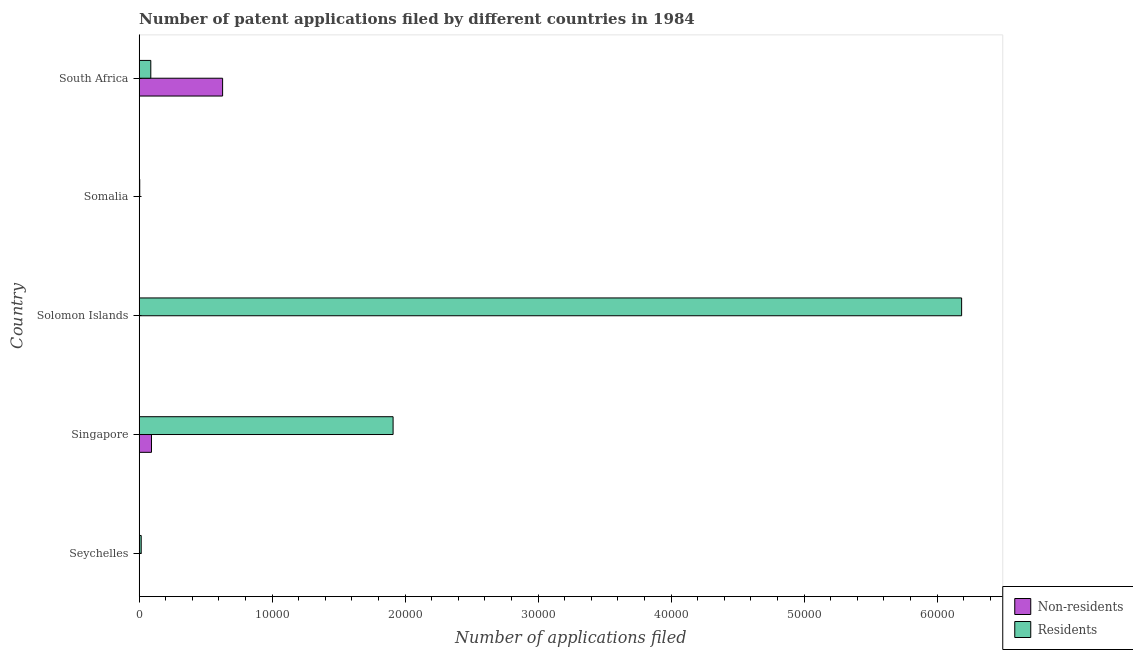How many groups of bars are there?
Your answer should be very brief. 5. Are the number of bars on each tick of the Y-axis equal?
Ensure brevity in your answer.  Yes. How many bars are there on the 2nd tick from the top?
Ensure brevity in your answer.  2. What is the label of the 3rd group of bars from the top?
Your response must be concise. Solomon Islands. In how many cases, is the number of bars for a given country not equal to the number of legend labels?
Your response must be concise. 0. What is the number of patent applications by residents in Seychelles?
Your response must be concise. 153. Across all countries, what is the maximum number of patent applications by residents?
Ensure brevity in your answer.  6.18e+04. Across all countries, what is the minimum number of patent applications by non residents?
Offer a very short reply. 1. In which country was the number of patent applications by non residents maximum?
Offer a terse response. South Africa. In which country was the number of patent applications by residents minimum?
Provide a short and direct response. Somalia. What is the total number of patent applications by non residents in the graph?
Give a very brief answer. 7222. What is the difference between the number of patent applications by residents in Solomon Islands and that in South Africa?
Offer a very short reply. 6.10e+04. What is the difference between the number of patent applications by residents in Somalia and the number of patent applications by non residents in Seychelles?
Your response must be concise. 42. What is the average number of patent applications by residents per country?
Provide a succinct answer. 1.64e+04. What is the difference between the number of patent applications by residents and number of patent applications by non residents in Singapore?
Offer a terse response. 1.82e+04. In how many countries, is the number of patent applications by non residents greater than 50000 ?
Offer a terse response. 0. What is the ratio of the number of patent applications by non residents in Singapore to that in Somalia?
Offer a very short reply. 132.43. Is the difference between the number of patent applications by residents in Seychelles and South Africa greater than the difference between the number of patent applications by non residents in Seychelles and South Africa?
Provide a succinct answer. Yes. What is the difference between the highest and the second highest number of patent applications by non residents?
Offer a terse response. 5348. What is the difference between the highest and the lowest number of patent applications by non residents?
Offer a very short reply. 6274. Is the sum of the number of patent applications by residents in Solomon Islands and South Africa greater than the maximum number of patent applications by non residents across all countries?
Your response must be concise. Yes. What does the 2nd bar from the top in Seychelles represents?
Your response must be concise. Non-residents. What does the 2nd bar from the bottom in South Africa represents?
Keep it short and to the point. Residents. How many countries are there in the graph?
Your response must be concise. 5. Are the values on the major ticks of X-axis written in scientific E-notation?
Keep it short and to the point. No. Does the graph contain any zero values?
Make the answer very short. No. How many legend labels are there?
Provide a short and direct response. 2. What is the title of the graph?
Give a very brief answer. Number of patent applications filed by different countries in 1984. What is the label or title of the X-axis?
Your answer should be very brief. Number of applications filed. What is the label or title of the Y-axis?
Offer a terse response. Country. What is the Number of applications filed of Residents in Seychelles?
Ensure brevity in your answer.  153. What is the Number of applications filed of Non-residents in Singapore?
Keep it short and to the point. 927. What is the Number of applications filed of Residents in Singapore?
Your answer should be very brief. 1.91e+04. What is the Number of applications filed of Residents in Solomon Islands?
Keep it short and to the point. 6.18e+04. What is the Number of applications filed of Non-residents in South Africa?
Provide a short and direct response. 6275. What is the Number of applications filed in Residents in South Africa?
Offer a terse response. 875. Across all countries, what is the maximum Number of applications filed in Non-residents?
Give a very brief answer. 6275. Across all countries, what is the maximum Number of applications filed of Residents?
Keep it short and to the point. 6.18e+04. Across all countries, what is the minimum Number of applications filed of Residents?
Your answer should be very brief. 43. What is the total Number of applications filed of Non-residents in the graph?
Ensure brevity in your answer.  7222. What is the total Number of applications filed of Residents in the graph?
Your response must be concise. 8.20e+04. What is the difference between the Number of applications filed in Non-residents in Seychelles and that in Singapore?
Your response must be concise. -926. What is the difference between the Number of applications filed in Residents in Seychelles and that in Singapore?
Keep it short and to the point. -1.89e+04. What is the difference between the Number of applications filed of Residents in Seychelles and that in Solomon Islands?
Keep it short and to the point. -6.17e+04. What is the difference between the Number of applications filed in Non-residents in Seychelles and that in Somalia?
Give a very brief answer. -6. What is the difference between the Number of applications filed of Residents in Seychelles and that in Somalia?
Your answer should be very brief. 110. What is the difference between the Number of applications filed of Non-residents in Seychelles and that in South Africa?
Offer a terse response. -6274. What is the difference between the Number of applications filed in Residents in Seychelles and that in South Africa?
Offer a very short reply. -722. What is the difference between the Number of applications filed of Non-residents in Singapore and that in Solomon Islands?
Make the answer very short. 915. What is the difference between the Number of applications filed in Residents in Singapore and that in Solomon Islands?
Your response must be concise. -4.27e+04. What is the difference between the Number of applications filed in Non-residents in Singapore and that in Somalia?
Keep it short and to the point. 920. What is the difference between the Number of applications filed in Residents in Singapore and that in Somalia?
Provide a succinct answer. 1.90e+04. What is the difference between the Number of applications filed of Non-residents in Singapore and that in South Africa?
Give a very brief answer. -5348. What is the difference between the Number of applications filed in Residents in Singapore and that in South Africa?
Provide a short and direct response. 1.82e+04. What is the difference between the Number of applications filed in Residents in Solomon Islands and that in Somalia?
Your answer should be very brief. 6.18e+04. What is the difference between the Number of applications filed in Non-residents in Solomon Islands and that in South Africa?
Keep it short and to the point. -6263. What is the difference between the Number of applications filed of Residents in Solomon Islands and that in South Africa?
Your response must be concise. 6.10e+04. What is the difference between the Number of applications filed of Non-residents in Somalia and that in South Africa?
Your answer should be very brief. -6268. What is the difference between the Number of applications filed of Residents in Somalia and that in South Africa?
Your answer should be very brief. -832. What is the difference between the Number of applications filed in Non-residents in Seychelles and the Number of applications filed in Residents in Singapore?
Offer a very short reply. -1.91e+04. What is the difference between the Number of applications filed in Non-residents in Seychelles and the Number of applications filed in Residents in Solomon Islands?
Offer a terse response. -6.18e+04. What is the difference between the Number of applications filed in Non-residents in Seychelles and the Number of applications filed in Residents in Somalia?
Your response must be concise. -42. What is the difference between the Number of applications filed in Non-residents in Seychelles and the Number of applications filed in Residents in South Africa?
Provide a succinct answer. -874. What is the difference between the Number of applications filed in Non-residents in Singapore and the Number of applications filed in Residents in Solomon Islands?
Offer a very short reply. -6.09e+04. What is the difference between the Number of applications filed in Non-residents in Singapore and the Number of applications filed in Residents in Somalia?
Your response must be concise. 884. What is the difference between the Number of applications filed in Non-residents in Solomon Islands and the Number of applications filed in Residents in Somalia?
Offer a terse response. -31. What is the difference between the Number of applications filed of Non-residents in Solomon Islands and the Number of applications filed of Residents in South Africa?
Ensure brevity in your answer.  -863. What is the difference between the Number of applications filed of Non-residents in Somalia and the Number of applications filed of Residents in South Africa?
Provide a short and direct response. -868. What is the average Number of applications filed of Non-residents per country?
Your answer should be compact. 1444.4. What is the average Number of applications filed of Residents per country?
Your answer should be very brief. 1.64e+04. What is the difference between the Number of applications filed in Non-residents and Number of applications filed in Residents in Seychelles?
Your response must be concise. -152. What is the difference between the Number of applications filed in Non-residents and Number of applications filed in Residents in Singapore?
Your response must be concise. -1.82e+04. What is the difference between the Number of applications filed of Non-residents and Number of applications filed of Residents in Solomon Islands?
Give a very brief answer. -6.18e+04. What is the difference between the Number of applications filed in Non-residents and Number of applications filed in Residents in Somalia?
Your response must be concise. -36. What is the difference between the Number of applications filed in Non-residents and Number of applications filed in Residents in South Africa?
Make the answer very short. 5400. What is the ratio of the Number of applications filed in Non-residents in Seychelles to that in Singapore?
Make the answer very short. 0. What is the ratio of the Number of applications filed of Residents in Seychelles to that in Singapore?
Your response must be concise. 0.01. What is the ratio of the Number of applications filed in Non-residents in Seychelles to that in Solomon Islands?
Ensure brevity in your answer.  0.08. What is the ratio of the Number of applications filed of Residents in Seychelles to that in Solomon Islands?
Offer a terse response. 0. What is the ratio of the Number of applications filed in Non-residents in Seychelles to that in Somalia?
Make the answer very short. 0.14. What is the ratio of the Number of applications filed of Residents in Seychelles to that in Somalia?
Keep it short and to the point. 3.56. What is the ratio of the Number of applications filed of Non-residents in Seychelles to that in South Africa?
Your response must be concise. 0. What is the ratio of the Number of applications filed in Residents in Seychelles to that in South Africa?
Ensure brevity in your answer.  0.17. What is the ratio of the Number of applications filed of Non-residents in Singapore to that in Solomon Islands?
Make the answer very short. 77.25. What is the ratio of the Number of applications filed in Residents in Singapore to that in Solomon Islands?
Provide a short and direct response. 0.31. What is the ratio of the Number of applications filed in Non-residents in Singapore to that in Somalia?
Offer a terse response. 132.43. What is the ratio of the Number of applications filed of Residents in Singapore to that in Somalia?
Offer a very short reply. 444.02. What is the ratio of the Number of applications filed of Non-residents in Singapore to that in South Africa?
Keep it short and to the point. 0.15. What is the ratio of the Number of applications filed in Residents in Singapore to that in South Africa?
Your answer should be very brief. 21.82. What is the ratio of the Number of applications filed in Non-residents in Solomon Islands to that in Somalia?
Your answer should be very brief. 1.71. What is the ratio of the Number of applications filed in Residents in Solomon Islands to that in Somalia?
Your answer should be compact. 1438.16. What is the ratio of the Number of applications filed in Non-residents in Solomon Islands to that in South Africa?
Keep it short and to the point. 0. What is the ratio of the Number of applications filed of Residents in Solomon Islands to that in South Africa?
Your response must be concise. 70.68. What is the ratio of the Number of applications filed in Non-residents in Somalia to that in South Africa?
Provide a succinct answer. 0. What is the ratio of the Number of applications filed of Residents in Somalia to that in South Africa?
Give a very brief answer. 0.05. What is the difference between the highest and the second highest Number of applications filed in Non-residents?
Your answer should be compact. 5348. What is the difference between the highest and the second highest Number of applications filed in Residents?
Provide a short and direct response. 4.27e+04. What is the difference between the highest and the lowest Number of applications filed in Non-residents?
Ensure brevity in your answer.  6274. What is the difference between the highest and the lowest Number of applications filed in Residents?
Provide a succinct answer. 6.18e+04. 